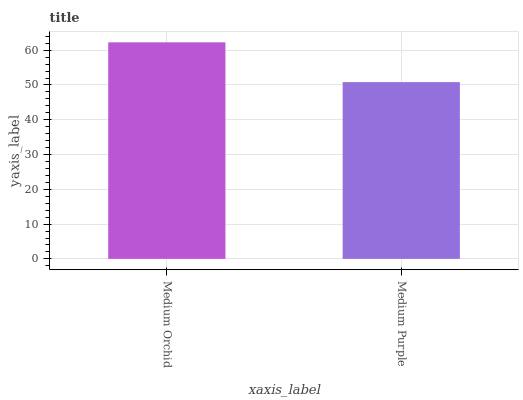Is Medium Purple the minimum?
Answer yes or no. Yes. Is Medium Orchid the maximum?
Answer yes or no. Yes. Is Medium Purple the maximum?
Answer yes or no. No. Is Medium Orchid greater than Medium Purple?
Answer yes or no. Yes. Is Medium Purple less than Medium Orchid?
Answer yes or no. Yes. Is Medium Purple greater than Medium Orchid?
Answer yes or no. No. Is Medium Orchid less than Medium Purple?
Answer yes or no. No. Is Medium Orchid the high median?
Answer yes or no. Yes. Is Medium Purple the low median?
Answer yes or no. Yes. Is Medium Purple the high median?
Answer yes or no. No. Is Medium Orchid the low median?
Answer yes or no. No. 